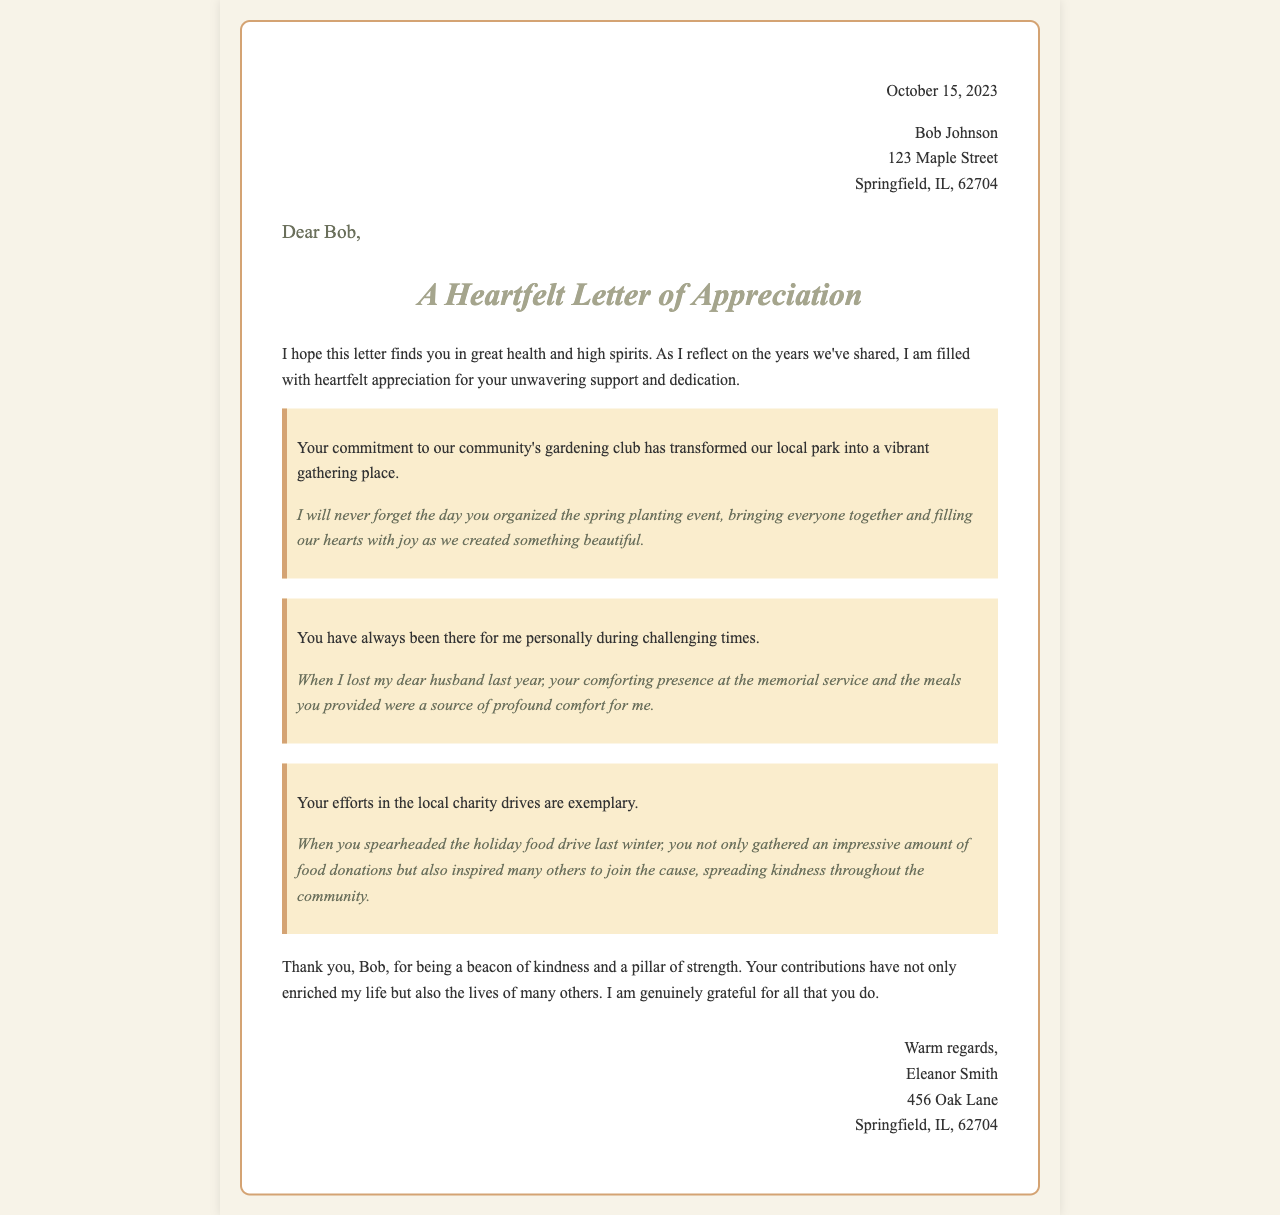What is the date of the letter? The date of the letter is stated at the top, which is October 15, 2023.
Answer: October 15, 2023 Who is the recipient of the letter? The letter is addressed to Bob Johnson, as mentioned in the header.
Answer: Bob Johnson What is the author's name? The name of the author, who expresses appreciation, is Eleanor Smith, which is found in the signature.
Answer: Eleanor Smith What was organized by Bob that brought the community together? The letter notes that Bob organized a spring planting event, highlighting his contributions to the gardening club.
Answer: Spring planting event What significant event did Bob support during the author's time of loss? Bob’s presence at the memorial service was specifically mentioned as a supportive gesture during a difficult time for the author.
Answer: Memorial service What type of community involvement does the letter highlight? The letter emphasizes Bob's involvement in charity drives, specifically mentioning the holiday food drive.
Answer: Charity drives What is the tone of the letter? The overall tone of the letter is one of heartfelt appreciation, clearly evident in the expressions of gratitude throughout the document.
Answer: Heartfelt appreciation Which community location was positively impacted by Bob's contributions? The local park was transformed into a vibrant gathering place due to Bob's commitment to the gardening club.
Answer: Local park What form of comfort did Bob provide after the author's loss? The letter notes that Bob provided meals that were a source of comfort for the author during her challenging times.
Answer: Meals 